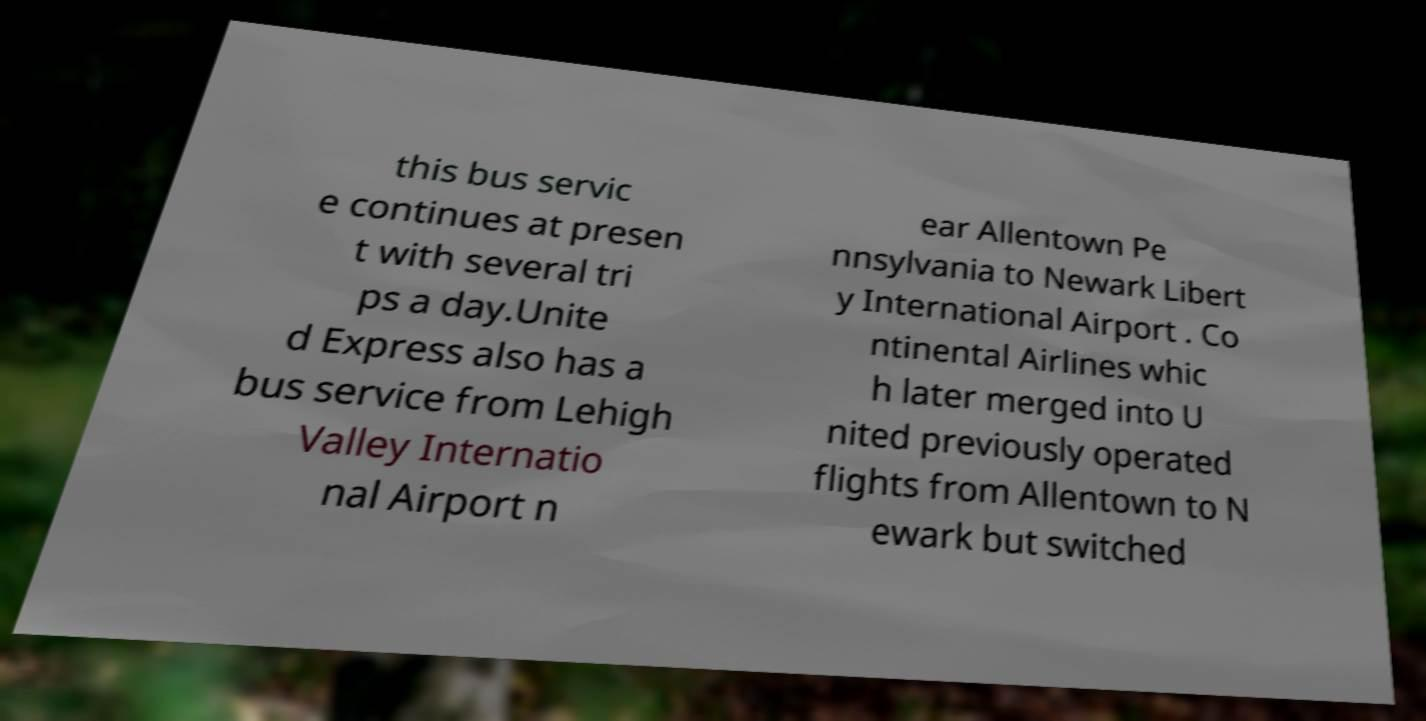Can you accurately transcribe the text from the provided image for me? this bus servic e continues at presen t with several tri ps a day.Unite d Express also has a bus service from Lehigh Valley Internatio nal Airport n ear Allentown Pe nnsylvania to Newark Libert y International Airport . Co ntinental Airlines whic h later merged into U nited previously operated flights from Allentown to N ewark but switched 